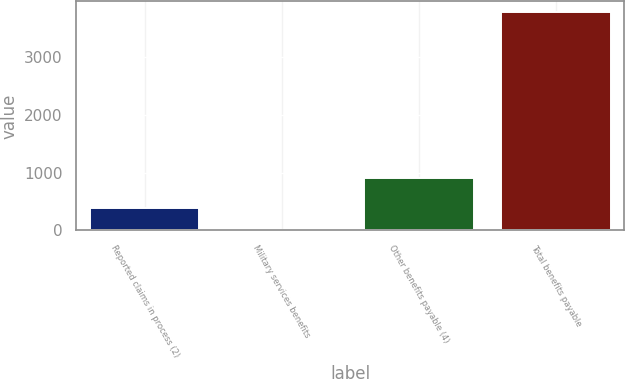Convert chart to OTSL. <chart><loc_0><loc_0><loc_500><loc_500><bar_chart><fcel>Reported claims in process (2)<fcel>Military services benefits<fcel>Other benefits payable (4)<fcel>Total benefits payable<nl><fcel>381.5<fcel>4<fcel>908<fcel>3779<nl></chart> 